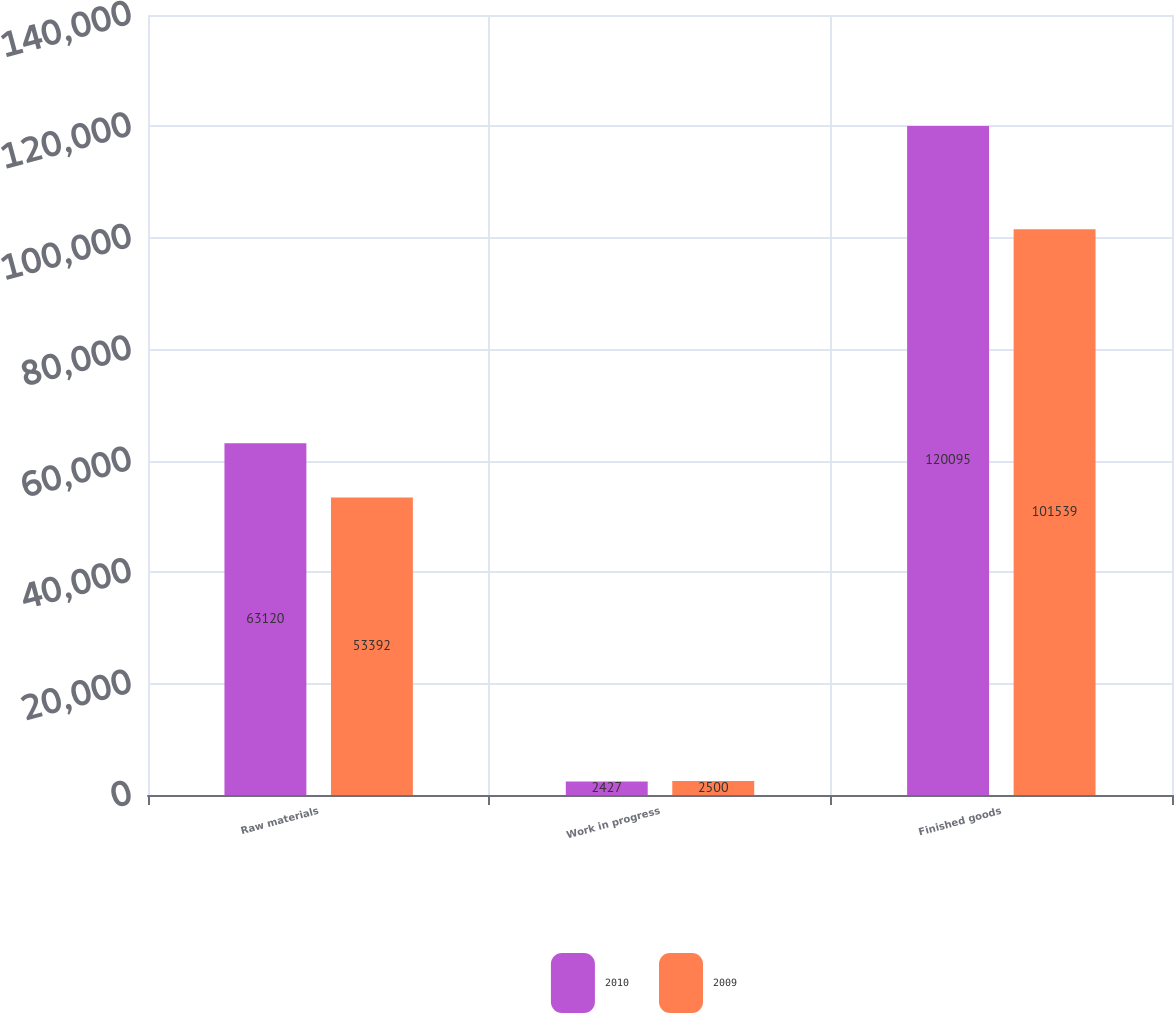Convert chart to OTSL. <chart><loc_0><loc_0><loc_500><loc_500><stacked_bar_chart><ecel><fcel>Raw materials<fcel>Work in progress<fcel>Finished goods<nl><fcel>2010<fcel>63120<fcel>2427<fcel>120095<nl><fcel>2009<fcel>53392<fcel>2500<fcel>101539<nl></chart> 